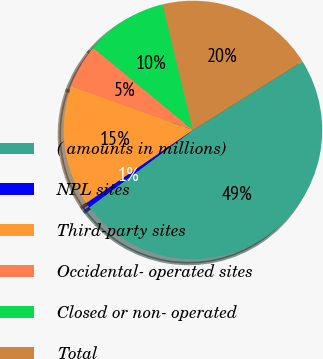<chart> <loc_0><loc_0><loc_500><loc_500><pie_chart><fcel>( amounts in millions)<fcel>NPL sites<fcel>Third-party sites<fcel>Occidental- operated sites<fcel>Closed or non- operated<fcel>Total<nl><fcel>48.7%<fcel>0.65%<fcel>15.07%<fcel>5.46%<fcel>10.26%<fcel>19.87%<nl></chart> 